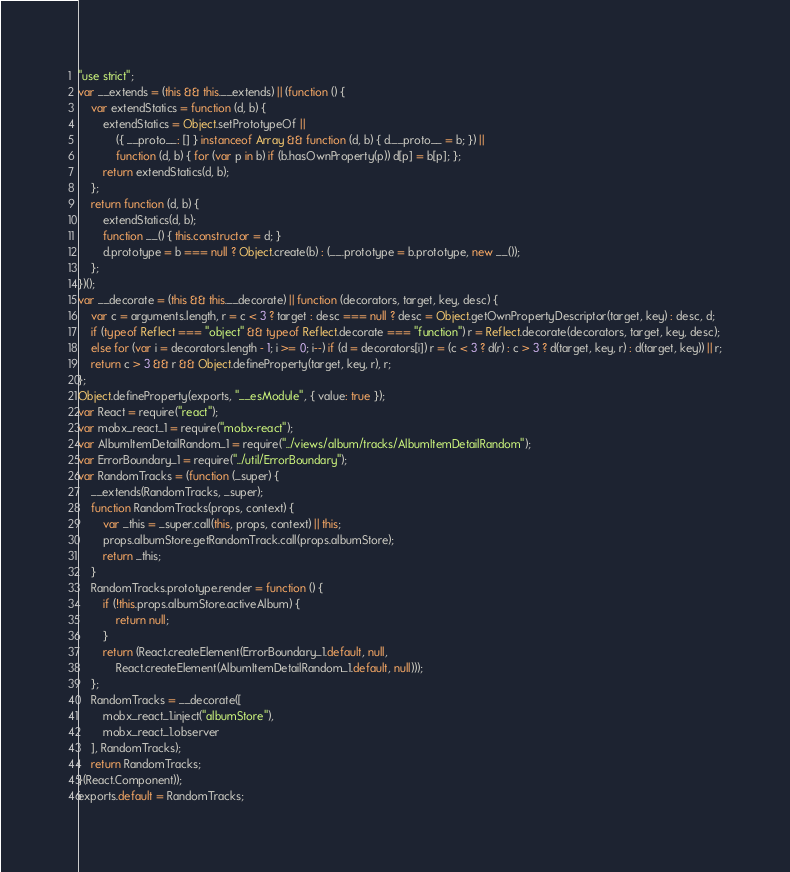Convert code to text. <code><loc_0><loc_0><loc_500><loc_500><_JavaScript_>"use strict";
var __extends = (this && this.__extends) || (function () {
    var extendStatics = function (d, b) {
        extendStatics = Object.setPrototypeOf ||
            ({ __proto__: [] } instanceof Array && function (d, b) { d.__proto__ = b; }) ||
            function (d, b) { for (var p in b) if (b.hasOwnProperty(p)) d[p] = b[p]; };
        return extendStatics(d, b);
    };
    return function (d, b) {
        extendStatics(d, b);
        function __() { this.constructor = d; }
        d.prototype = b === null ? Object.create(b) : (__.prototype = b.prototype, new __());
    };
})();
var __decorate = (this && this.__decorate) || function (decorators, target, key, desc) {
    var c = arguments.length, r = c < 3 ? target : desc === null ? desc = Object.getOwnPropertyDescriptor(target, key) : desc, d;
    if (typeof Reflect === "object" && typeof Reflect.decorate === "function") r = Reflect.decorate(decorators, target, key, desc);
    else for (var i = decorators.length - 1; i >= 0; i--) if (d = decorators[i]) r = (c < 3 ? d(r) : c > 3 ? d(target, key, r) : d(target, key)) || r;
    return c > 3 && r && Object.defineProperty(target, key, r), r;
};
Object.defineProperty(exports, "__esModule", { value: true });
var React = require("react");
var mobx_react_1 = require("mobx-react");
var AlbumItemDetailRandom_1 = require("../views/album/tracks/AlbumItemDetailRandom");
var ErrorBoundary_1 = require("../util/ErrorBoundary");
var RandomTracks = (function (_super) {
    __extends(RandomTracks, _super);
    function RandomTracks(props, context) {
        var _this = _super.call(this, props, context) || this;
        props.albumStore.getRandomTrack.call(props.albumStore);
        return _this;
    }
    RandomTracks.prototype.render = function () {
        if (!this.props.albumStore.activeAlbum) {
            return null;
        }
        return (React.createElement(ErrorBoundary_1.default, null,
            React.createElement(AlbumItemDetailRandom_1.default, null)));
    };
    RandomTracks = __decorate([
        mobx_react_1.inject("albumStore"),
        mobx_react_1.observer
    ], RandomTracks);
    return RandomTracks;
}(React.Component));
exports.default = RandomTracks;
</code> 